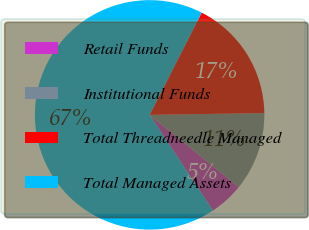Convert chart to OTSL. <chart><loc_0><loc_0><loc_500><loc_500><pie_chart><fcel>Retail Funds<fcel>Institutional Funds<fcel>Total Threadneedle Managed<fcel>Total Managed Assets<nl><fcel>4.88%<fcel>11.07%<fcel>17.26%<fcel>66.78%<nl></chart> 